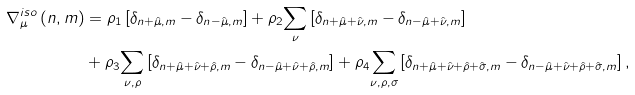<formula> <loc_0><loc_0><loc_500><loc_500>\nabla ^ { i s o } _ { \mu } \left ( n , m \right ) & = \rho _ { 1 } \left [ \delta _ { n + \hat { \mu } , m } - \delta _ { n - \hat { \mu } , m } \right ] + \rho _ { 2 } \underset { \nu } { \sum } \left [ \delta _ { n + \hat { \mu } + \hat { \nu } , m } - \delta _ { n - \hat { \mu } + \hat { \nu } , m } \right ] \\ & + \rho _ { 3 } \underset { \nu , \rho } { \sum } \left [ \delta _ { n + \hat { \mu } + \hat { \nu } + \hat { \rho } , m } - \delta _ { n - \hat { \mu } + \hat { \nu } + \hat { \rho } , m } \right ] + \rho _ { 4 } \underset { \nu , \rho , \sigma } { \sum } \left [ \delta _ { n + \hat { \mu } + \hat { \nu } + \hat { \rho } + \hat { \sigma } , m } - \delta _ { n - \hat { \mu } + \hat { \nu } + \hat { \rho } + \hat { \sigma } , m } \right ] ,</formula> 